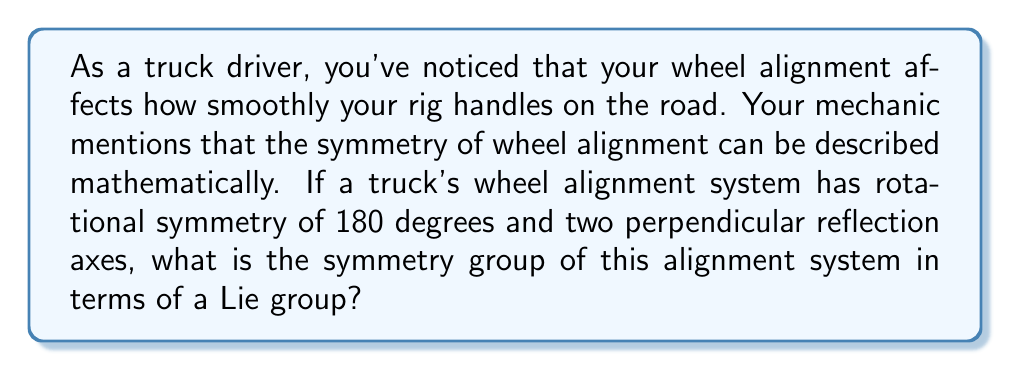Show me your answer to this math problem. To determine the symmetry group of the truck's wheel alignment system, let's break down the problem step-by-step:

1. Identify the symmetries:
   - 180-degree rotational symmetry
   - Two perpendicular reflection axes

2. These symmetries correspond to the following transformations:
   - Rotation by 180 degrees: $R_{180}$
   - Reflection across axis 1: $M_1$
   - Reflection across axis 2: $M_2$
   - Identity transformation: $I$

3. The group formed by these transformations is isomorphic to the dihedral group $D_2$, also known as the Klein four-group $V_4$.

4. In terms of Lie groups, this symmetry group corresponds to the orthogonal group $O(2)$, which is the group of 2×2 orthogonal matrices.

5. The Lie algebra associated with $O(2)$ is $\mathfrak{so}(2)$, which consists of 2×2 skew-symmetric matrices:

   $$\mathfrak{so}(2) = \left\{ \begin{pmatrix} 0 & -\theta \\ \theta & 0 \end{pmatrix} : \theta \in \mathbb{R} \right\}$$

6. The discrete subgroup of $O(2)$ that represents our specific symmetries can be written as:

   $$\left\{ \begin{pmatrix} 1 & 0 \\ 0 & 1 \end{pmatrix}, \begin{pmatrix} -1 & 0 \\ 0 & -1 \end{pmatrix}, \begin{pmatrix} 1 & 0 \\ 0 & -1 \end{pmatrix}, \begin{pmatrix} -1 & 0 \\ 0 & 1 \end{pmatrix} \right\}$$

   These matrices correspond to $I$, $R_{180}$, $M_1$, and $M_2$ respectively.

Therefore, the symmetry group of the truck's wheel alignment system can be described as a discrete subgroup of the Lie group $O(2)$, isomorphic to the dihedral group $D_2$ or Klein four-group $V_4$.
Answer: The symmetry group of the truck's wheel alignment system is a discrete subgroup of the Lie group $O(2)$, isomorphic to $D_2$ (or $V_4$). 